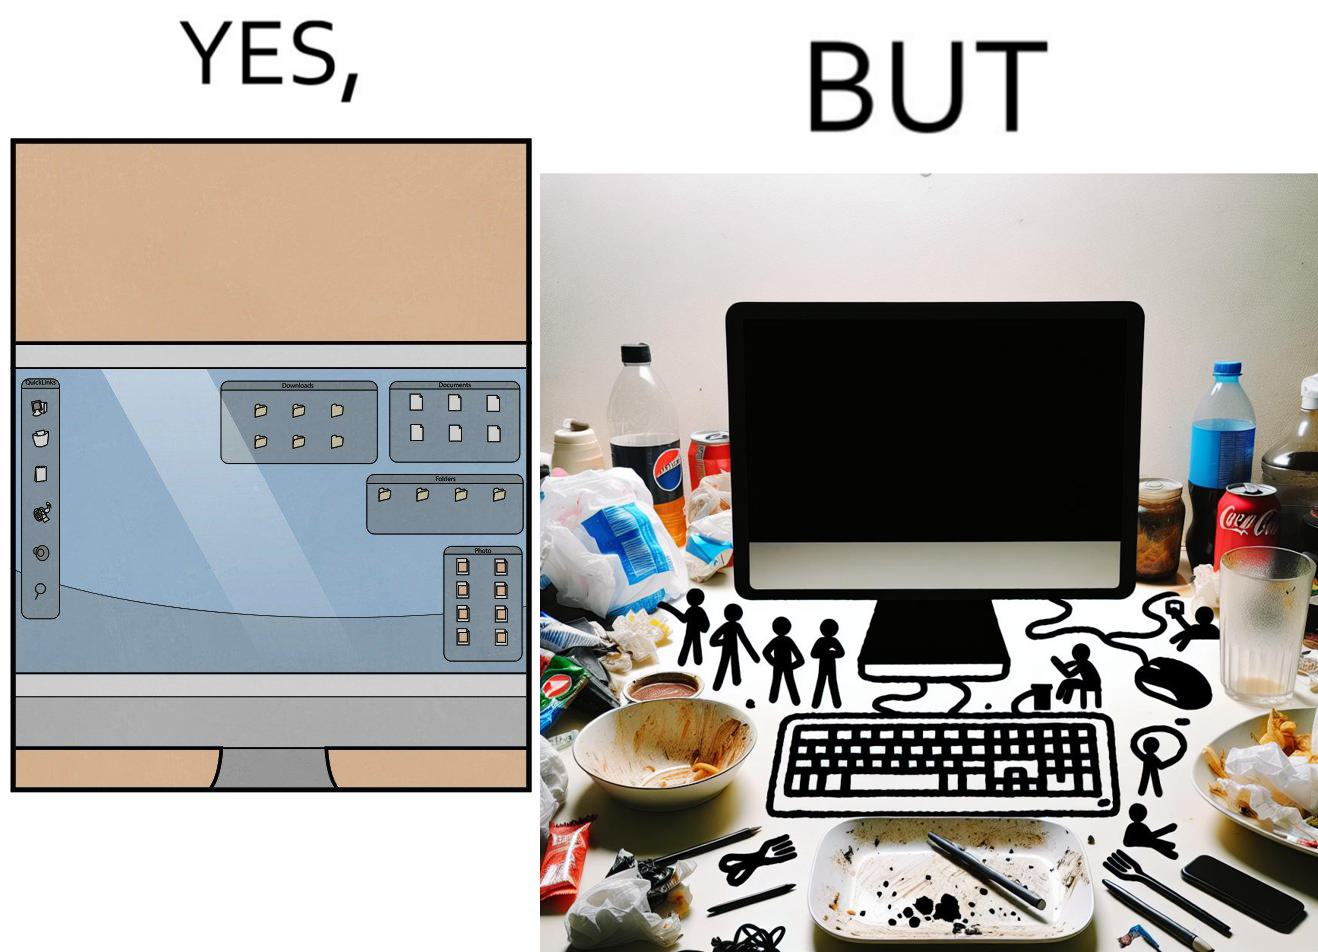What do you see in each half of this image? In the left part of the image: A desktop screen opened in a computer monitor. In the right part of the image: A desktop screen opened in a computer monitor on a table littered with used food packets, dirty plates, and wrappers 